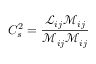<formula> <loc_0><loc_0><loc_500><loc_500>C _ { s } ^ { 2 } = { \frac { { \mathcal { L } } _ { i j } { \mathcal { M } } _ { i j } } { { \mathcal { M } } _ { i j } { \mathcal { M } } _ { i j } } }</formula> 